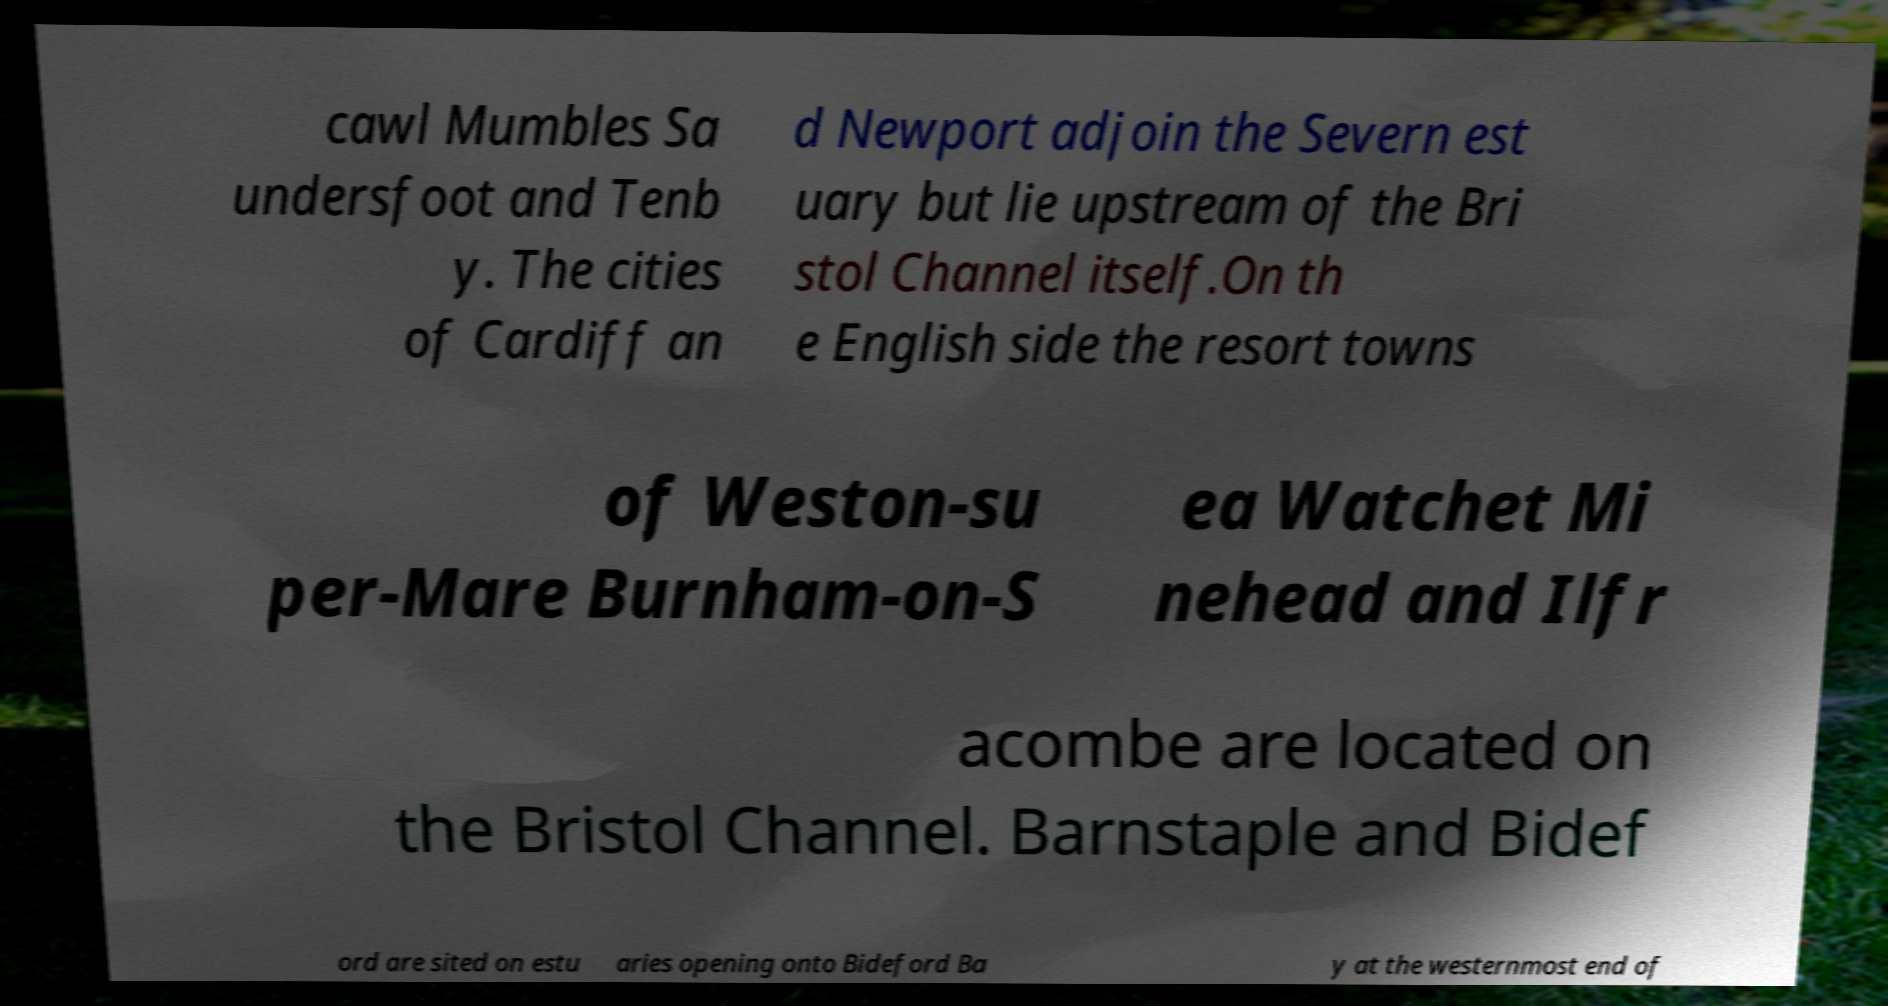I need the written content from this picture converted into text. Can you do that? cawl Mumbles Sa undersfoot and Tenb y. The cities of Cardiff an d Newport adjoin the Severn est uary but lie upstream of the Bri stol Channel itself.On th e English side the resort towns of Weston-su per-Mare Burnham-on-S ea Watchet Mi nehead and Ilfr acombe are located on the Bristol Channel. Barnstaple and Bidef ord are sited on estu aries opening onto Bideford Ba y at the westernmost end of 